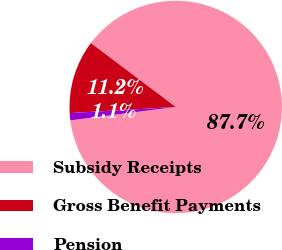Convert chart. <chart><loc_0><loc_0><loc_500><loc_500><pie_chart><fcel>Subsidy Receipts<fcel>Gross Benefit Payments<fcel>Pension<nl><fcel>87.71%<fcel>11.19%<fcel>1.1%<nl></chart> 